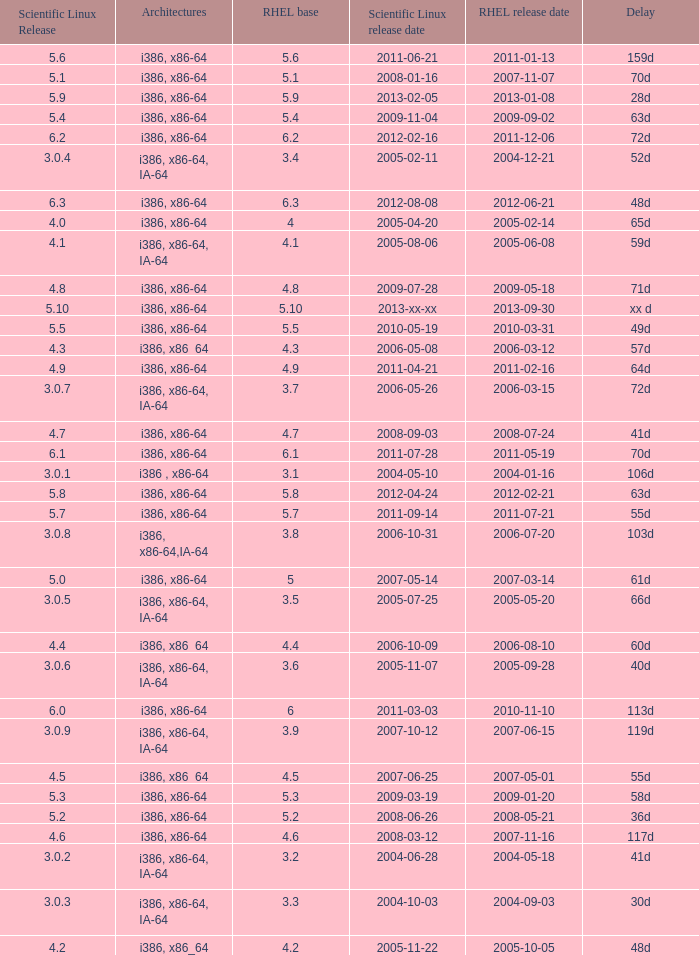When is the rhel release date when scientific linux release is 3.0.4 2004-12-21. 